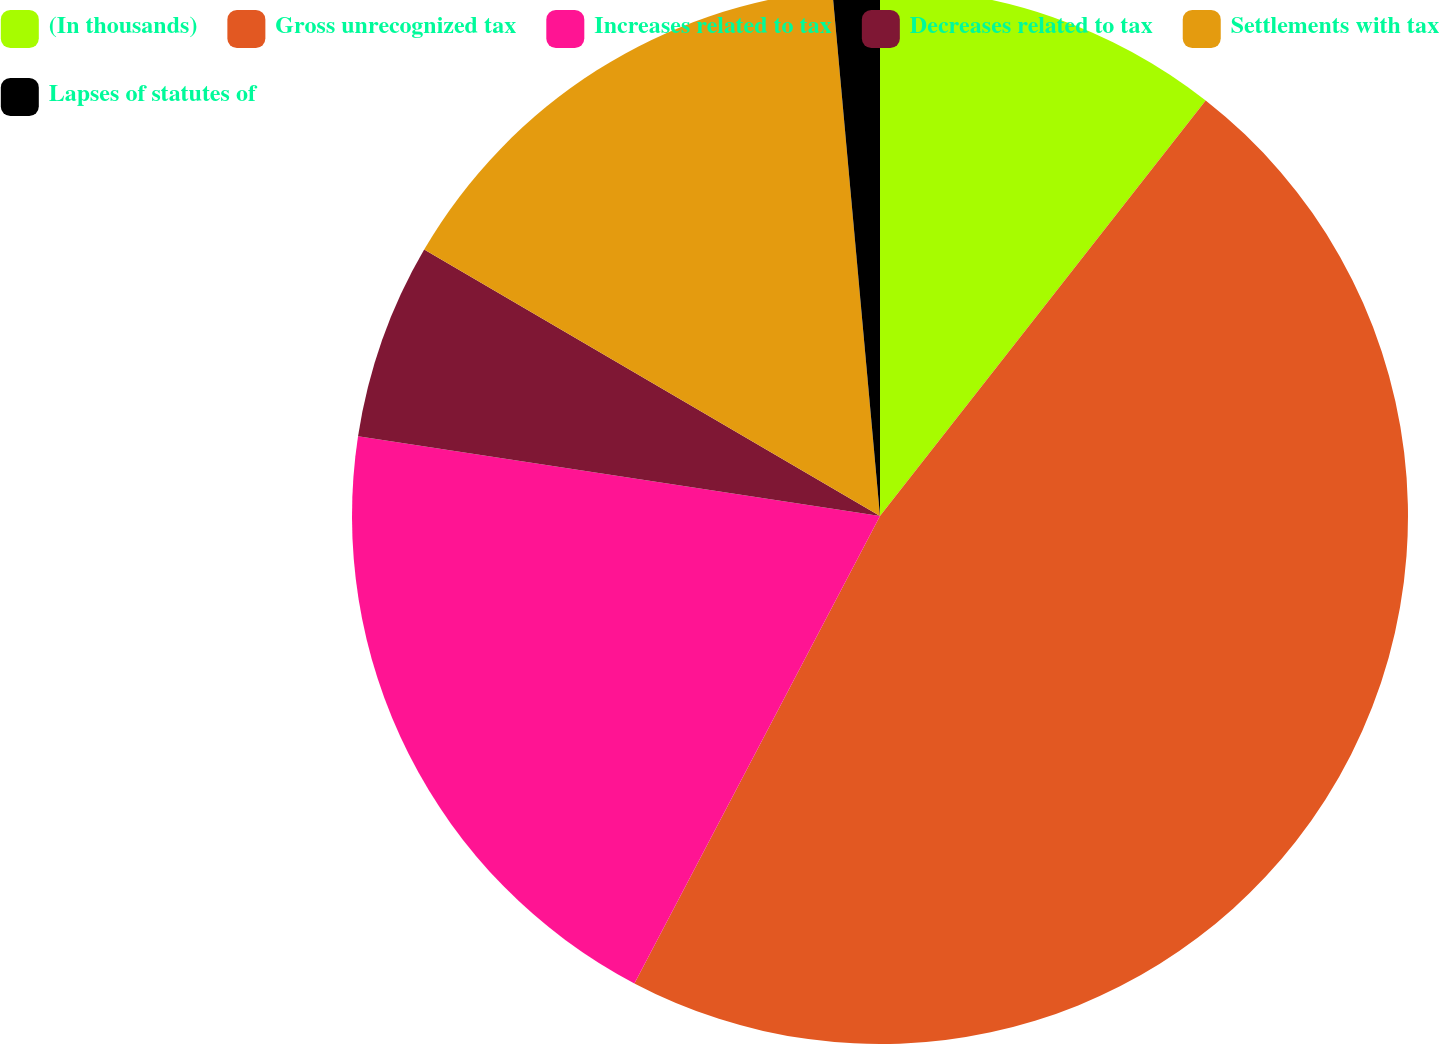<chart> <loc_0><loc_0><loc_500><loc_500><pie_chart><fcel>(In thousands)<fcel>Gross unrecognized tax<fcel>Increases related to tax<fcel>Decreases related to tax<fcel>Settlements with tax<fcel>Lapses of statutes of<nl><fcel>10.58%<fcel>47.12%<fcel>19.71%<fcel>6.01%<fcel>15.14%<fcel>1.44%<nl></chart> 